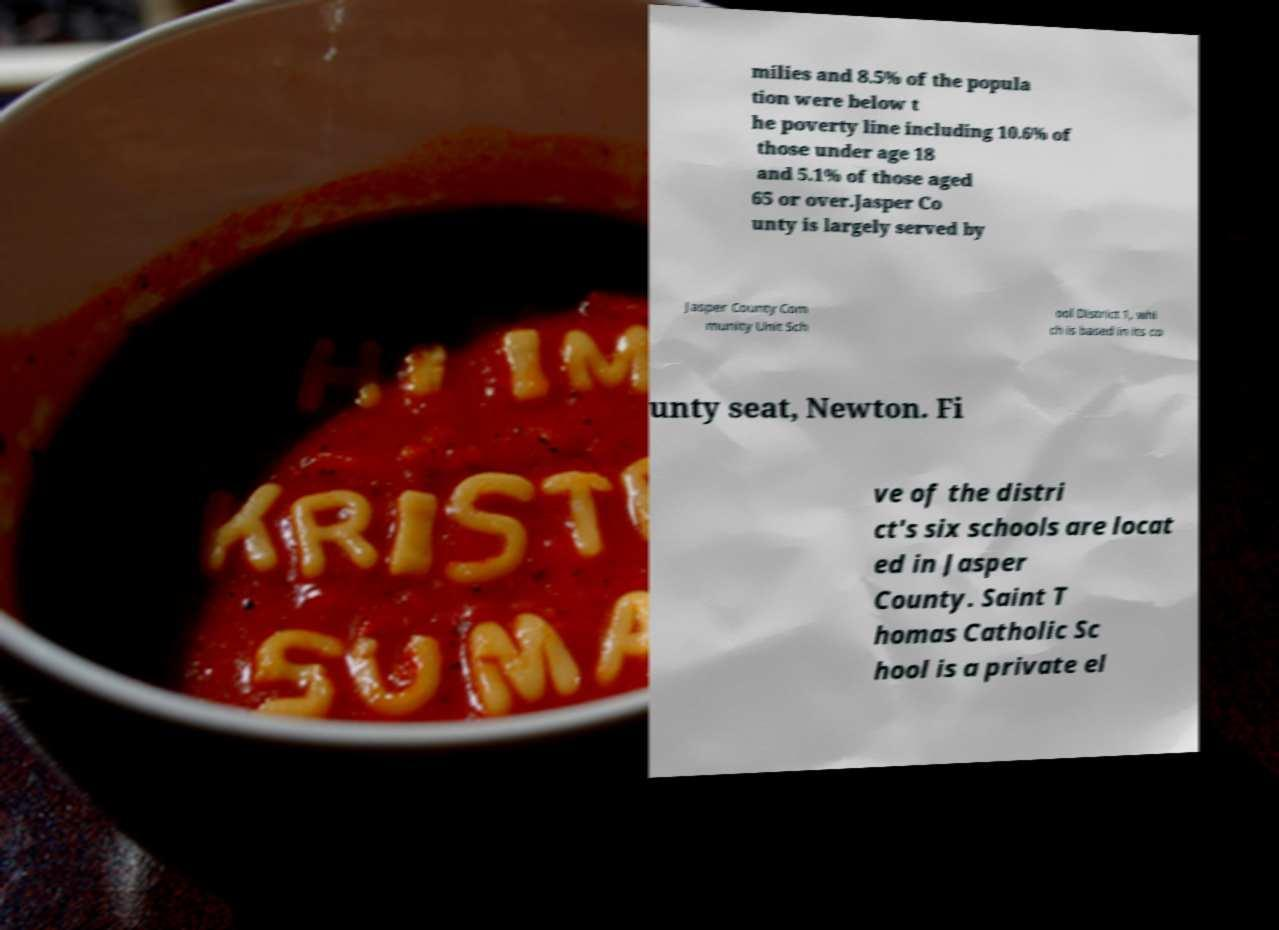Could you assist in decoding the text presented in this image and type it out clearly? milies and 8.5% of the popula tion were below t he poverty line including 10.6% of those under age 18 and 5.1% of those aged 65 or over.Jasper Co unty is largely served by Jasper County Com munity Unit Sch ool District 1, whi ch is based in its co unty seat, Newton. Fi ve of the distri ct's six schools are locat ed in Jasper County. Saint T homas Catholic Sc hool is a private el 